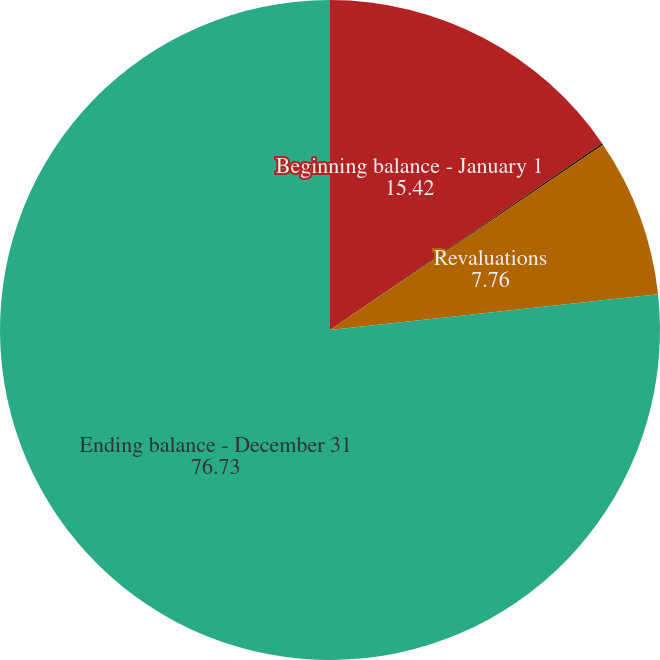Convert chart to OTSL. <chart><loc_0><loc_0><loc_500><loc_500><pie_chart><fcel>Beginning balance - January 1<fcel>Payments<fcel>Revaluations<fcel>Ending balance - December 31<nl><fcel>15.42%<fcel>0.09%<fcel>7.76%<fcel>76.73%<nl></chart> 